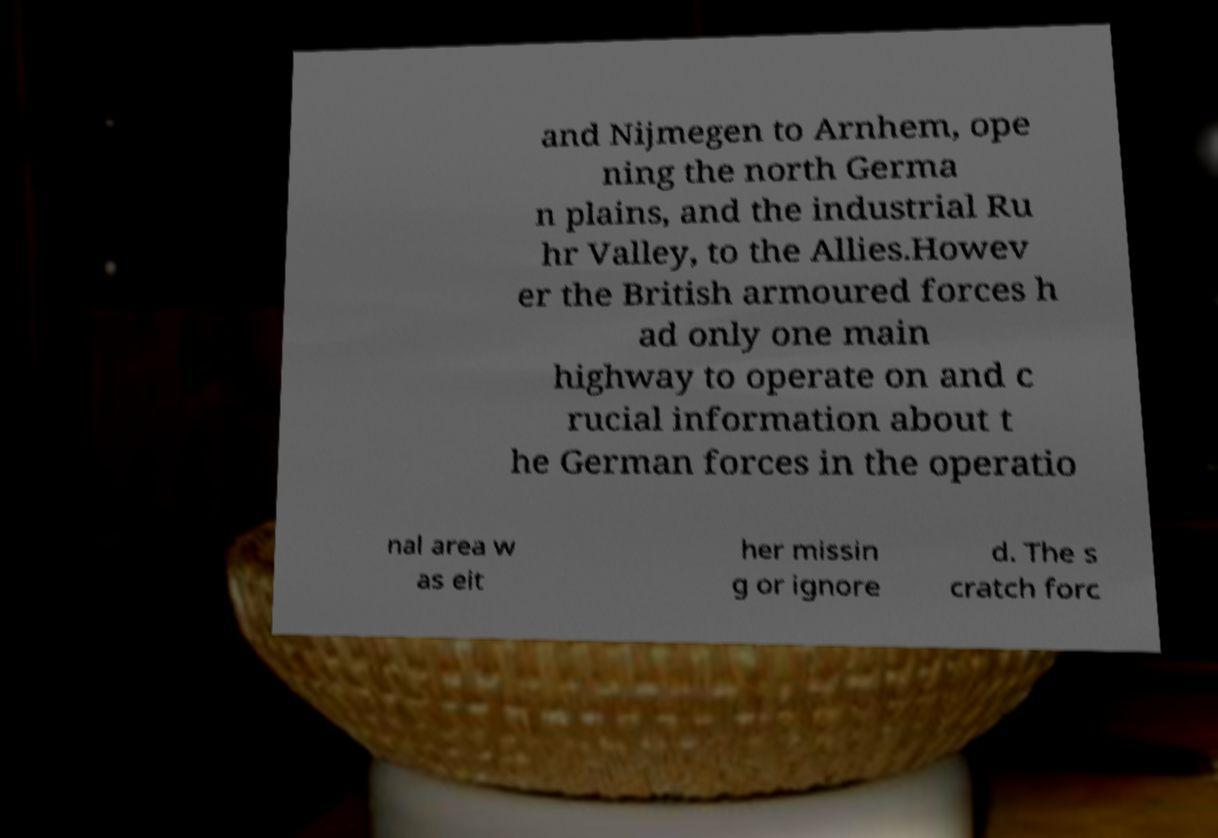What messages or text are displayed in this image? I need them in a readable, typed format. and Nijmegen to Arnhem, ope ning the north Germa n plains, and the industrial Ru hr Valley, to the Allies.Howev er the British armoured forces h ad only one main highway to operate on and c rucial information about t he German forces in the operatio nal area w as eit her missin g or ignore d. The s cratch forc 